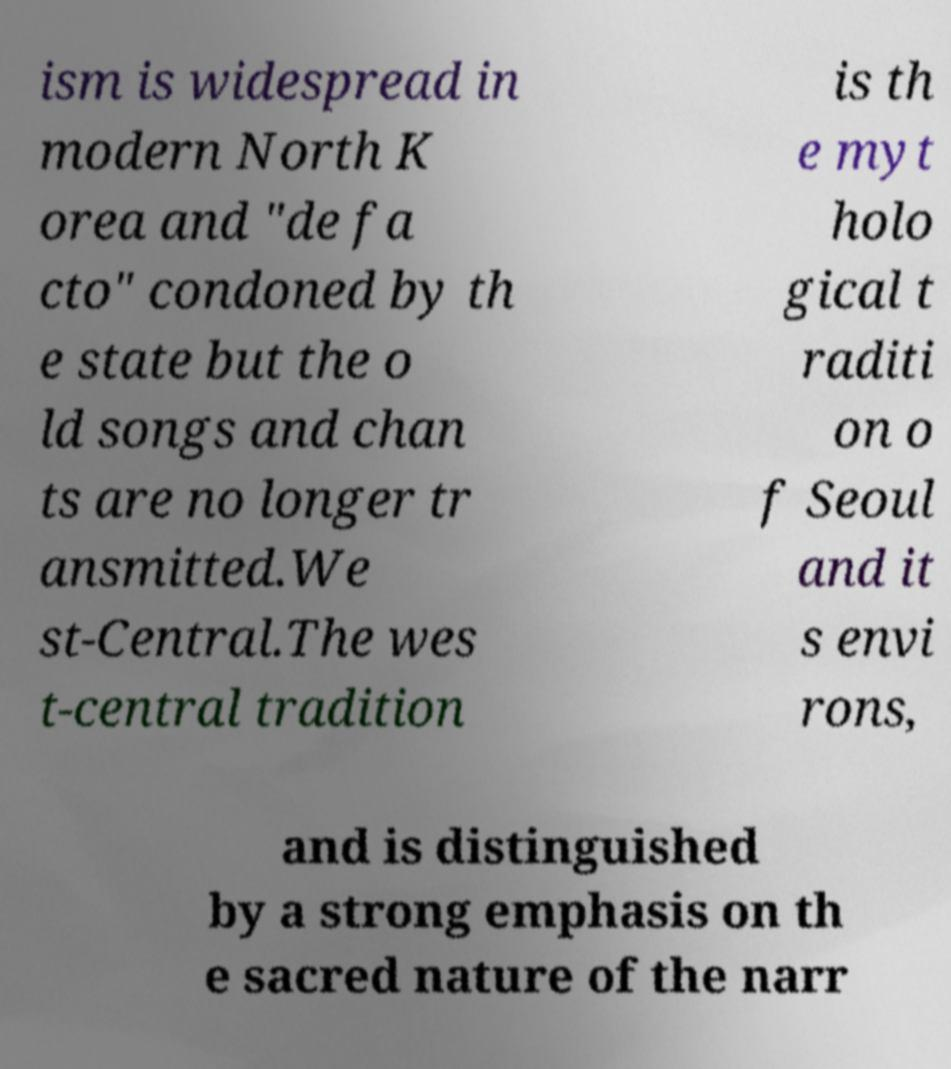For documentation purposes, I need the text within this image transcribed. Could you provide that? ism is widespread in modern North K orea and "de fa cto" condoned by th e state but the o ld songs and chan ts are no longer tr ansmitted.We st-Central.The wes t-central tradition is th e myt holo gical t raditi on o f Seoul and it s envi rons, and is distinguished by a strong emphasis on th e sacred nature of the narr 